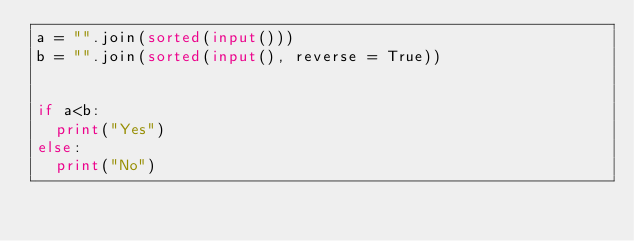<code> <loc_0><loc_0><loc_500><loc_500><_Python_>a = "".join(sorted(input()))
b = "".join(sorted(input(), reverse = True))


if a<b:
  print("Yes")
else:
  print("No")
</code> 